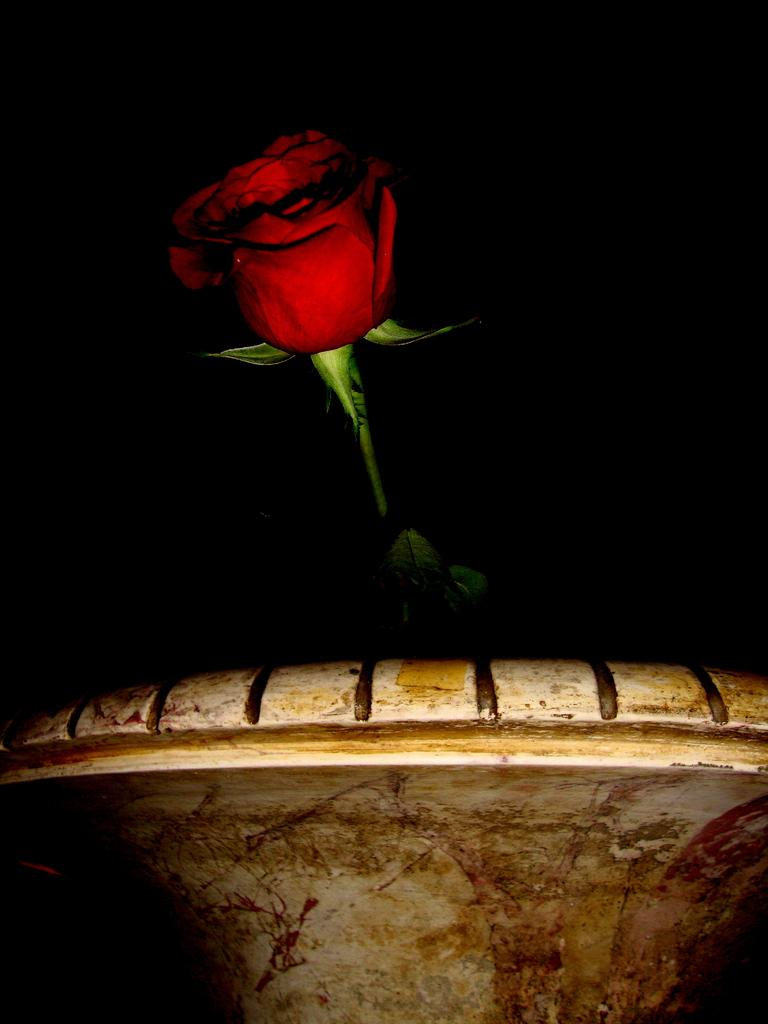What type of flower is in the image? There is a red color rose in the image. What piece of furniture is visible in the image? There is a chair in the front bottom side of the image. What color is the background of the image? The background of the image is black. Can you tell me how many basketballs are on the chair in the image? There are no basketballs present in the image; it only features a red color rose and a chair. What type of brake is visible in the image? There is no brake present in the image. 